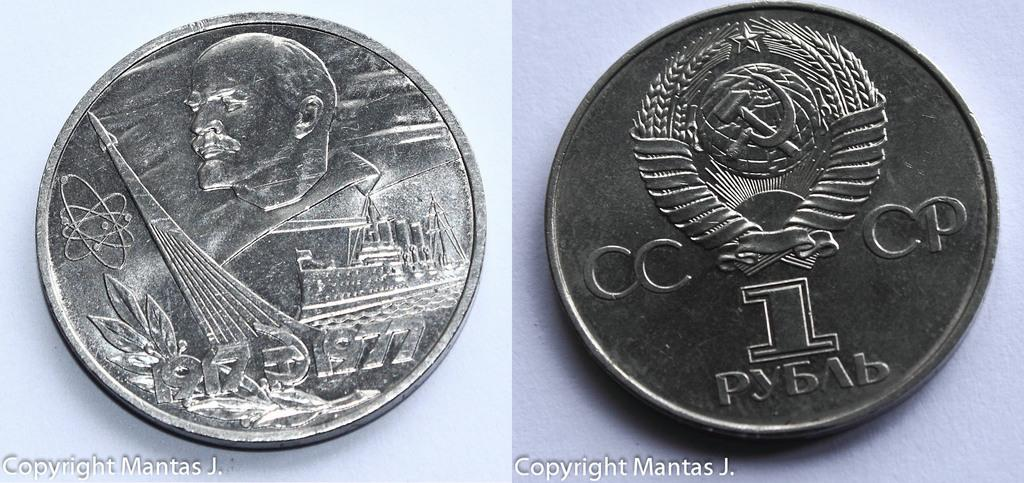<image>
Present a compact description of the photo's key features. The front face of a one rouble Russian coin has a picture of Lenin on it whilst the reverse bears the letters CCCP 